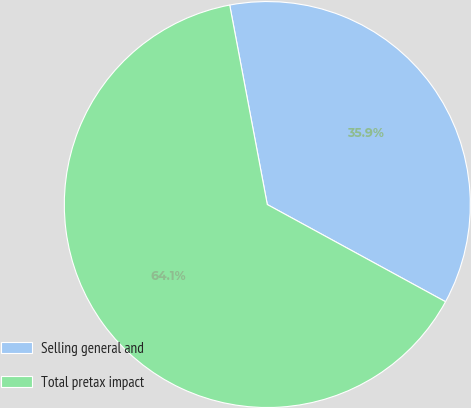<chart> <loc_0><loc_0><loc_500><loc_500><pie_chart><fcel>Selling general and<fcel>Total pretax impact<nl><fcel>35.91%<fcel>64.09%<nl></chart> 